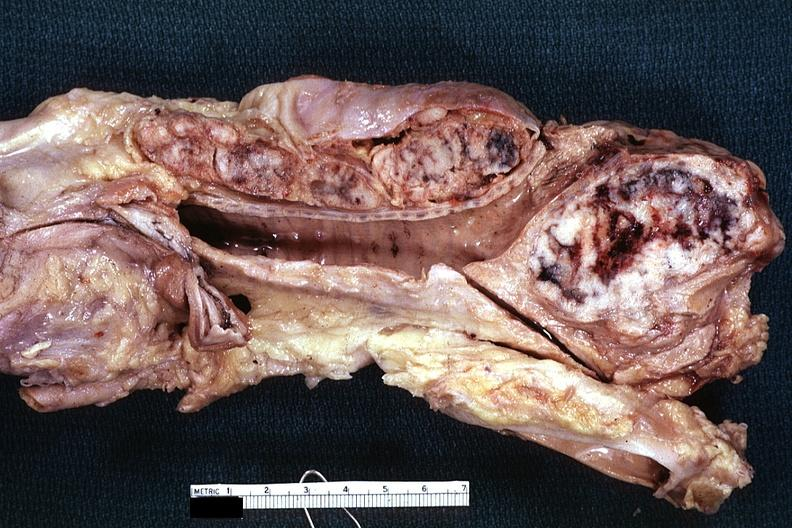s metastatic carcinoma present?
Answer the question using a single word or phrase. Yes 